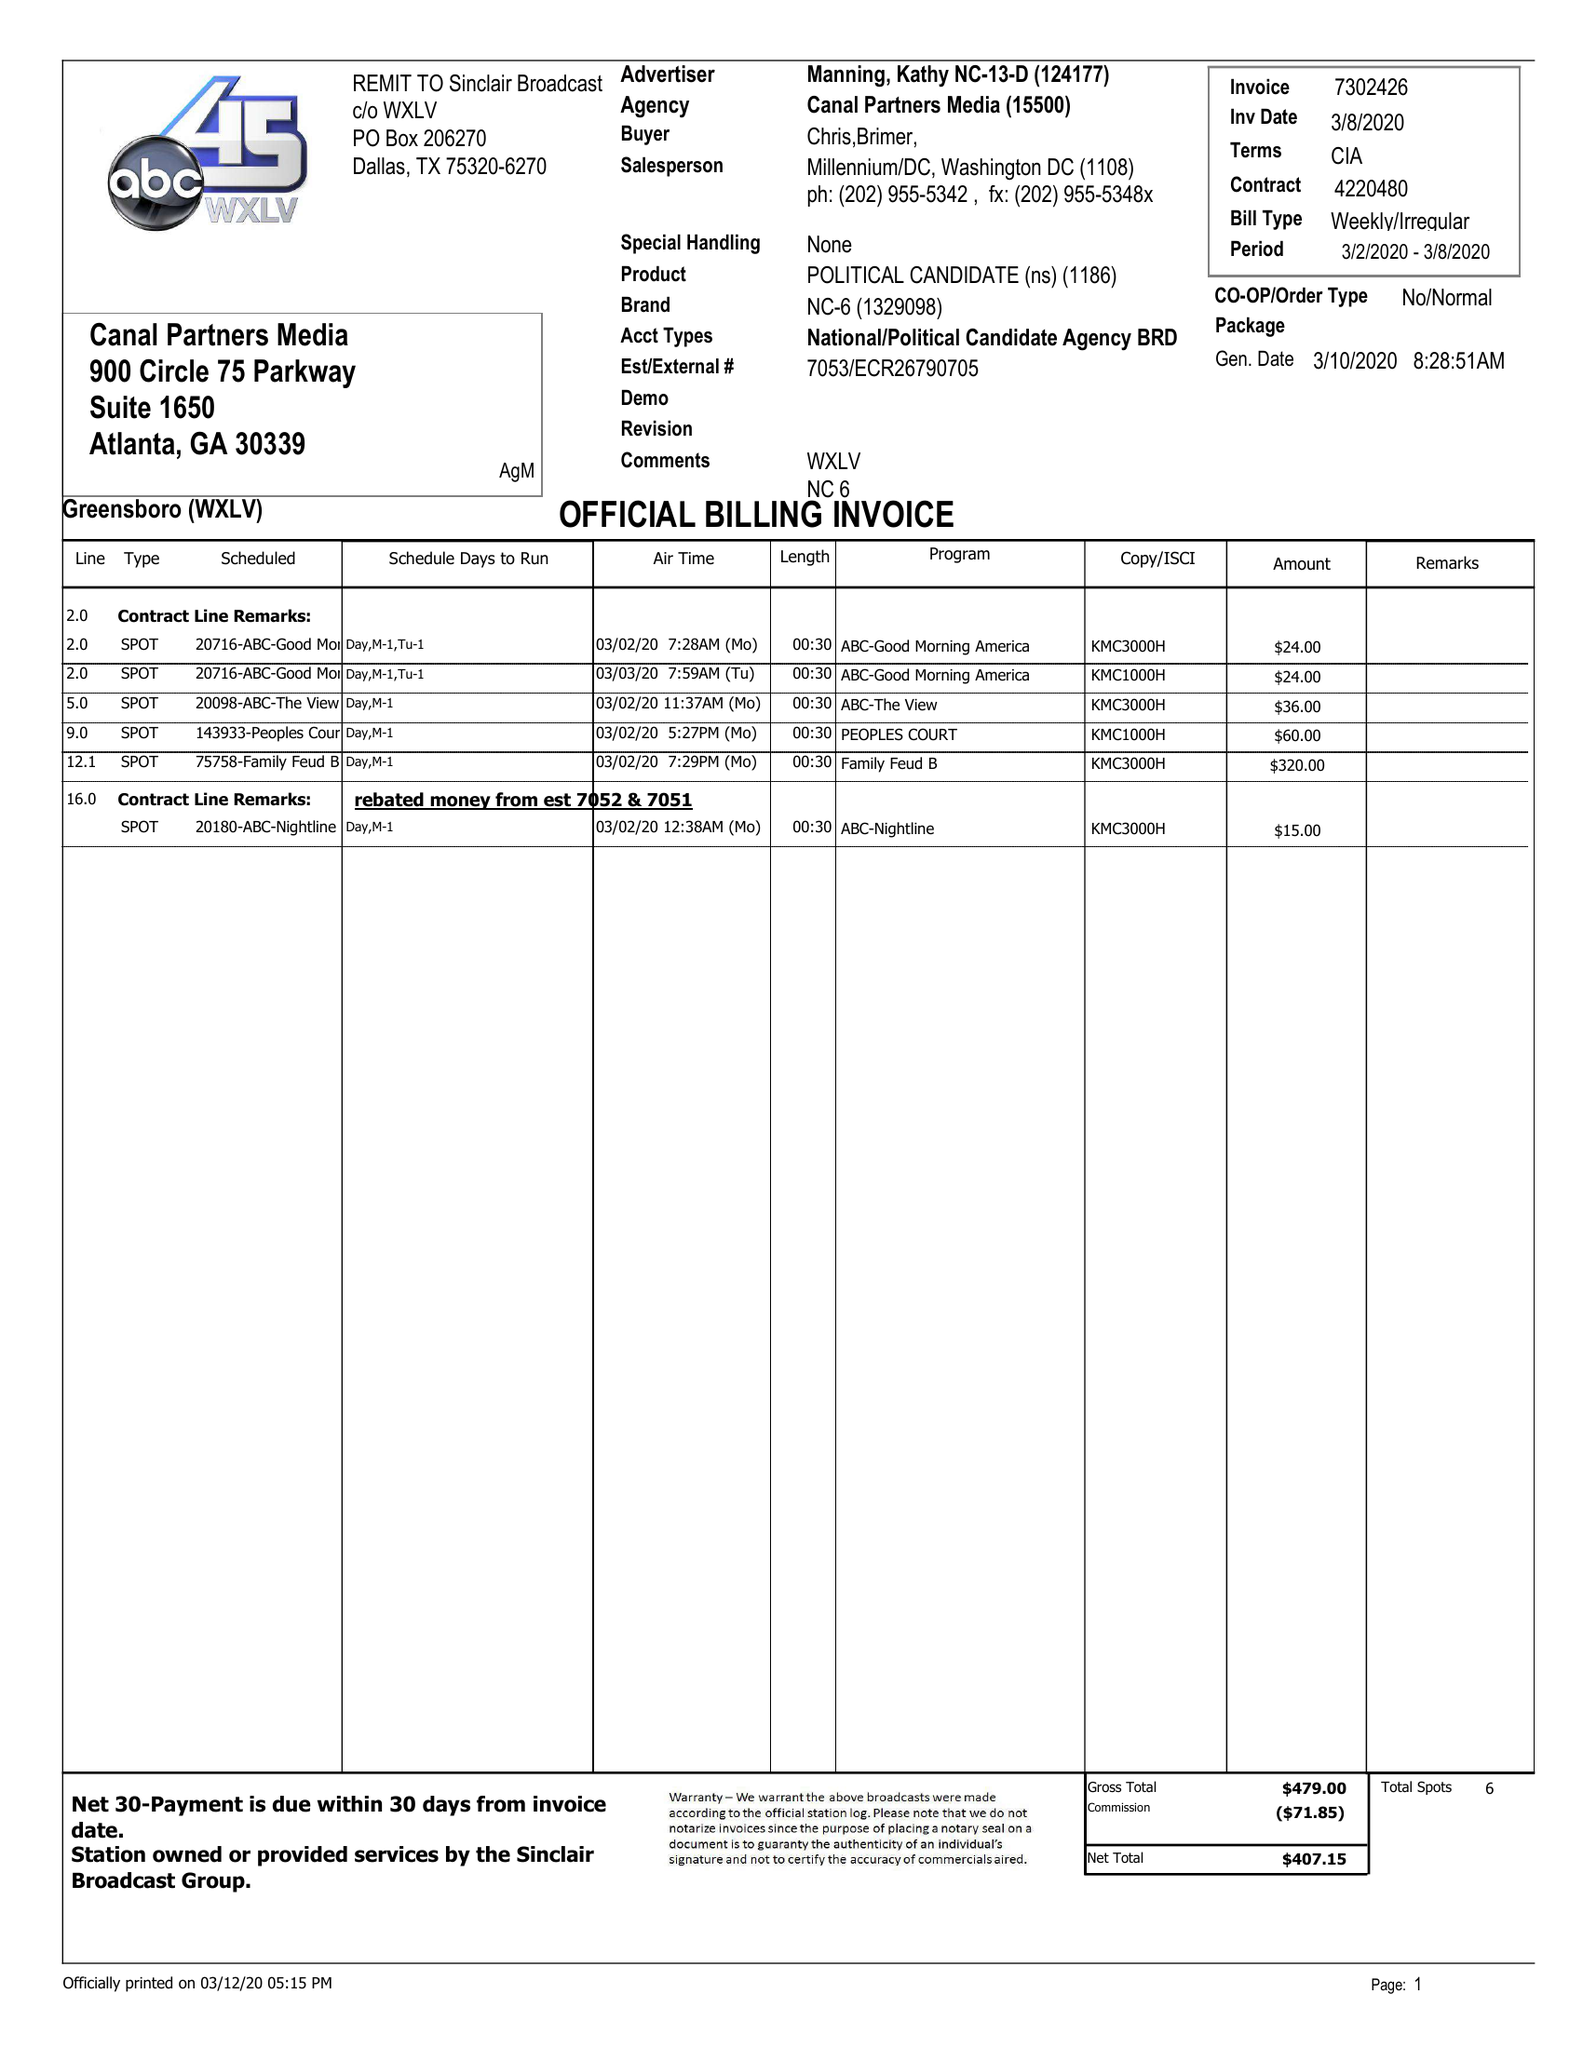What is the value for the advertiser?
Answer the question using a single word or phrase. MANNING, KATHY NC-13-D 